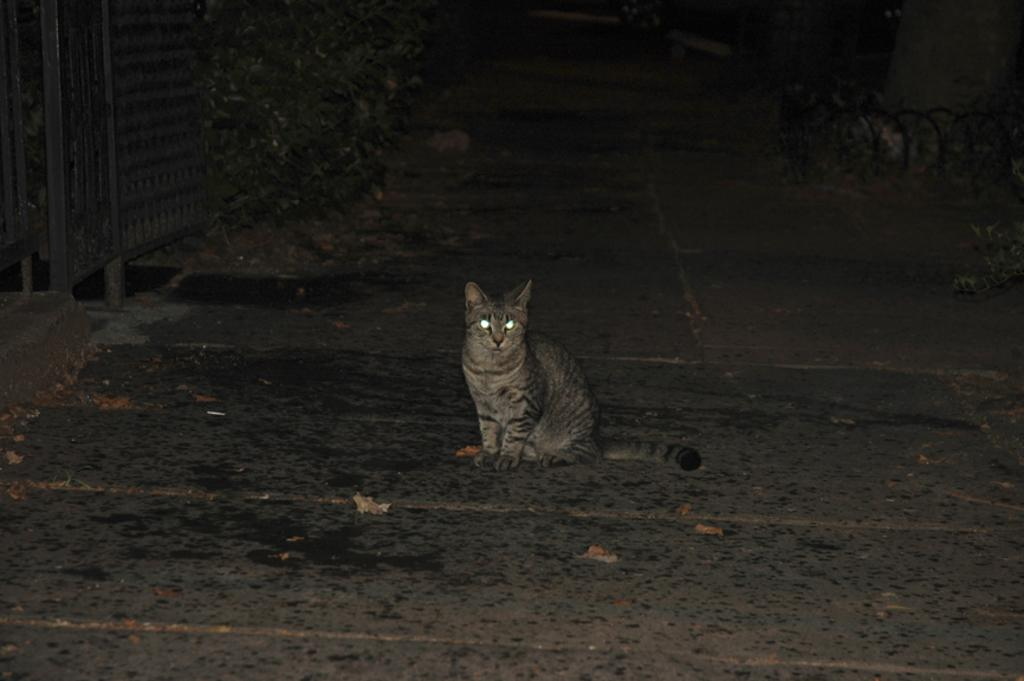What animal is sitting on the path in the image? There is a cat sitting on the path in the image. What can be seen in the background of the image? There are plants, grills, and a walkway visible in the background of the image. Are there any other objects visible in the background of the image? Yes, there are other objects visible in the background of the image. What type of reward is the cat holding in the image? There is no reward present in the image; the cat is simply sitting on the path. 